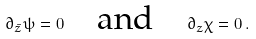Convert formula to latex. <formula><loc_0><loc_0><loc_500><loc_500>\partial _ { \bar { z } } \psi = 0 \quad \text {and} \quad \partial _ { z } \chi = 0 \, .</formula> 